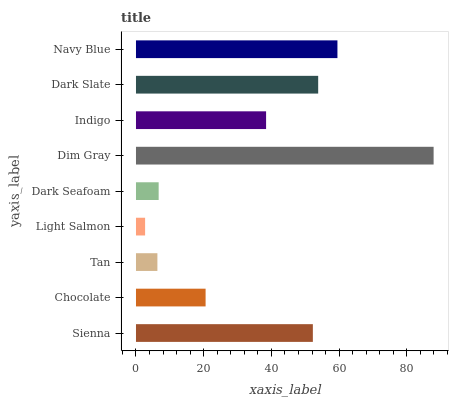Is Light Salmon the minimum?
Answer yes or no. Yes. Is Dim Gray the maximum?
Answer yes or no. Yes. Is Chocolate the minimum?
Answer yes or no. No. Is Chocolate the maximum?
Answer yes or no. No. Is Sienna greater than Chocolate?
Answer yes or no. Yes. Is Chocolate less than Sienna?
Answer yes or no. Yes. Is Chocolate greater than Sienna?
Answer yes or no. No. Is Sienna less than Chocolate?
Answer yes or no. No. Is Indigo the high median?
Answer yes or no. Yes. Is Indigo the low median?
Answer yes or no. Yes. Is Dark Seafoam the high median?
Answer yes or no. No. Is Chocolate the low median?
Answer yes or no. No. 